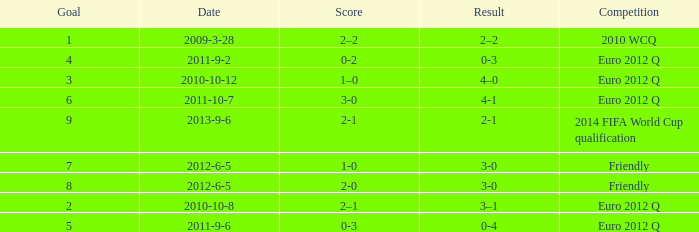How many goals when the score is 3-0 in the euro 2012 q? 1.0. 